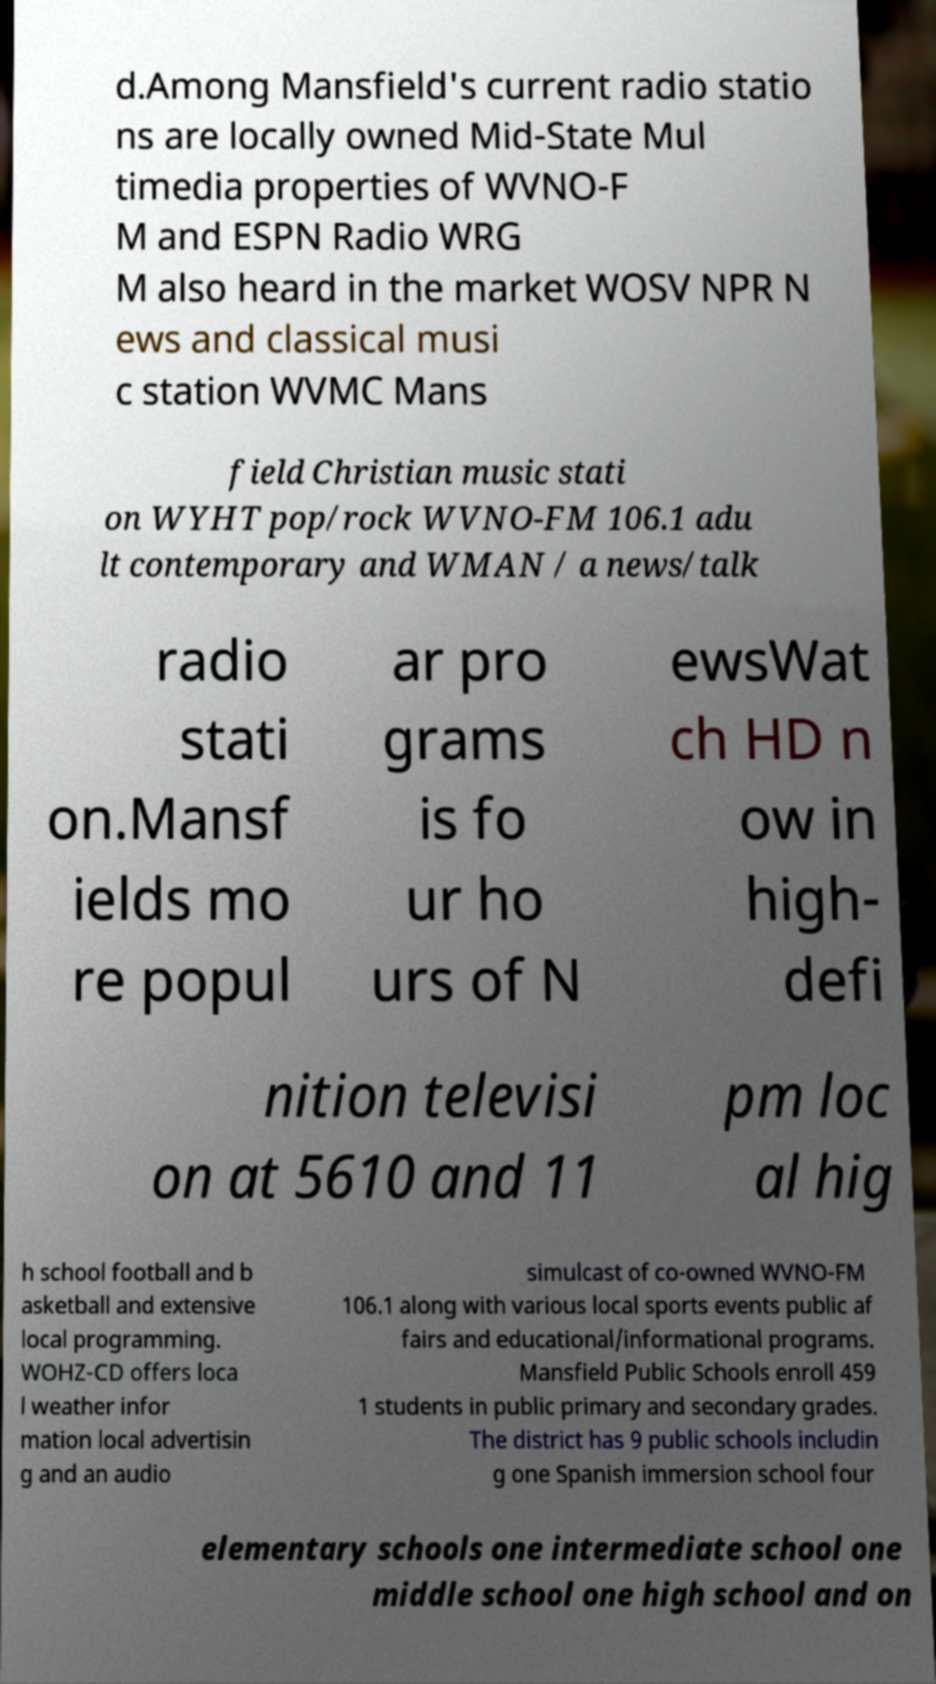Can you accurately transcribe the text from the provided image for me? d.Among Mansfield's current radio statio ns are locally owned Mid-State Mul timedia properties of WVNO-F M and ESPN Radio WRG M also heard in the market WOSV NPR N ews and classical musi c station WVMC Mans field Christian music stati on WYHT pop/rock WVNO-FM 106.1 adu lt contemporary and WMAN / a news/talk radio stati on.Mansf ields mo re popul ar pro grams is fo ur ho urs of N ewsWat ch HD n ow in high- defi nition televisi on at 5610 and 11 pm loc al hig h school football and b asketball and extensive local programming. WOHZ-CD offers loca l weather infor mation local advertisin g and an audio simulcast of co-owned WVNO-FM 106.1 along with various local sports events public af fairs and educational/informational programs. Mansfield Public Schools enroll 459 1 students in public primary and secondary grades. The district has 9 public schools includin g one Spanish immersion school four elementary schools one intermediate school one middle school one high school and on 